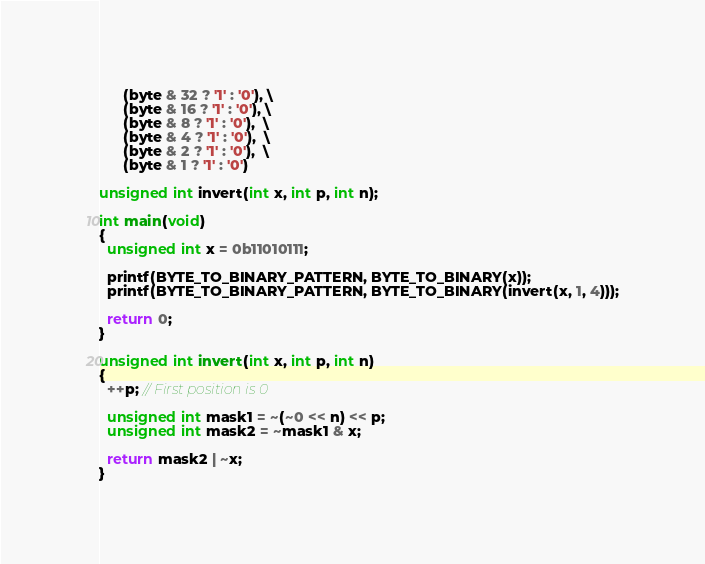<code> <loc_0><loc_0><loc_500><loc_500><_C_>      (byte & 32 ? '1' : '0'), \
      (byte & 16 ? '1' : '0'), \
      (byte & 8 ? '1' : '0'),  \
      (byte & 4 ? '1' : '0'),  \
      (byte & 2 ? '1' : '0'),  \
      (byte & 1 ? '1' : '0')

unsigned int invert(int x, int p, int n);

int main(void)
{
  unsigned int x = 0b11010111;

  printf(BYTE_TO_BINARY_PATTERN, BYTE_TO_BINARY(x));
  printf(BYTE_TO_BINARY_PATTERN, BYTE_TO_BINARY(invert(x, 1, 4)));

  return 0;
}

unsigned int invert(int x, int p, int n)
{
  ++p; // First position is 0

  unsigned int mask1 = ~(~0 << n) << p;
  unsigned int mask2 = ~mask1 & x;

  return mask2 | ~x;
}
</code> 